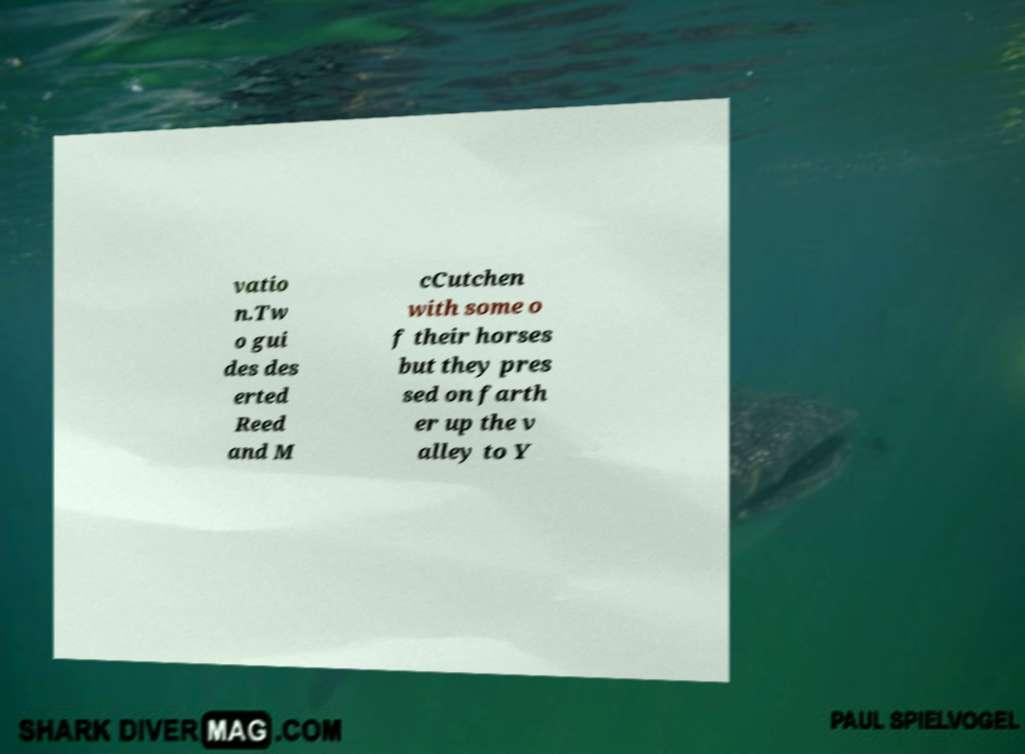Could you extract and type out the text from this image? vatio n.Tw o gui des des erted Reed and M cCutchen with some o f their horses but they pres sed on farth er up the v alley to Y 